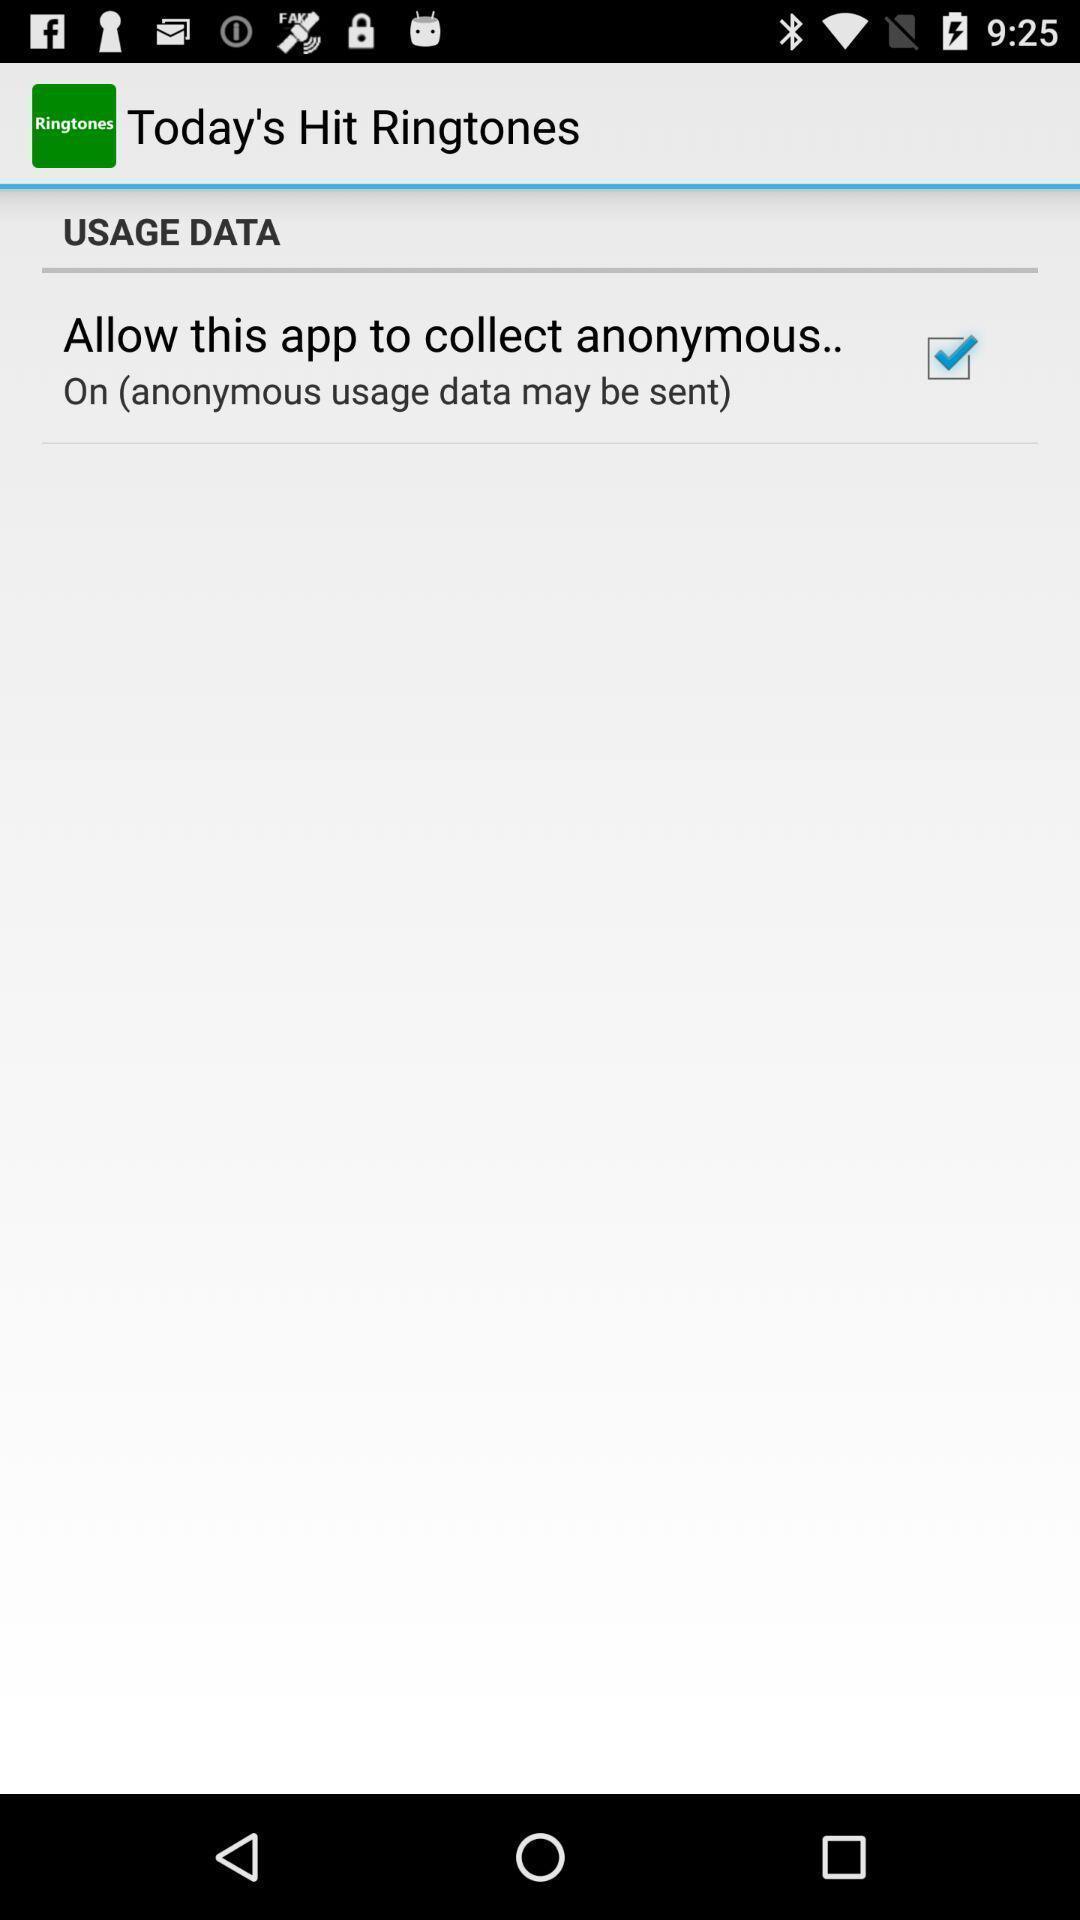What is the overall content of this screenshot? Screen showing usage data option of a music app. 